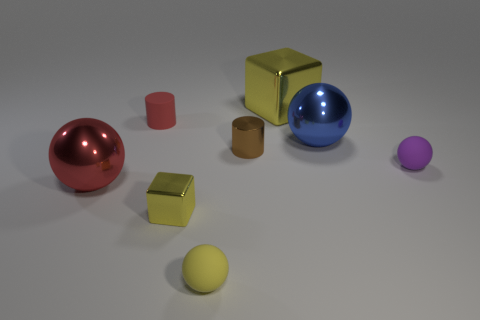The other metallic thing that is the same shape as the large yellow shiny thing is what color?
Your answer should be compact. Yellow. There is a shiny sphere in front of the blue shiny sphere; is its size the same as the small block?
Your response must be concise. No. What is the shape of the tiny rubber thing that is the same color as the large cube?
Provide a succinct answer. Sphere. How many big yellow cubes are made of the same material as the large red object?
Your answer should be compact. 1. What is the ball behind the brown metallic object right of the rubber cylinder behind the small brown shiny thing made of?
Your answer should be very brief. Metal. There is a matte ball in front of the small matte ball behind the large red metallic ball; what color is it?
Offer a very short reply. Yellow. What is the color of the block that is the same size as the purple ball?
Offer a terse response. Yellow. What number of big objects are blue metallic things or purple spheres?
Offer a terse response. 1. Are there more objects on the left side of the tiny yellow shiny object than large blue balls that are to the right of the purple thing?
Provide a short and direct response. Yes. What size is the other cube that is the same color as the big metallic cube?
Give a very brief answer. Small. 